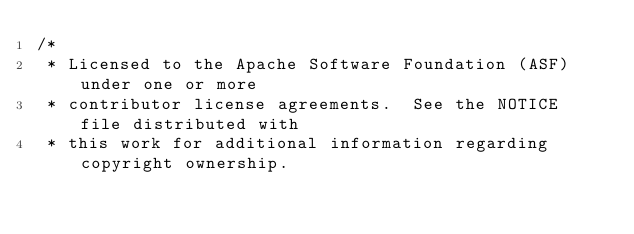Convert code to text. <code><loc_0><loc_0><loc_500><loc_500><_Java_>/*
 * Licensed to the Apache Software Foundation (ASF) under one or more
 * contributor license agreements.  See the NOTICE file distributed with
 * this work for additional information regarding copyright ownership.</code> 